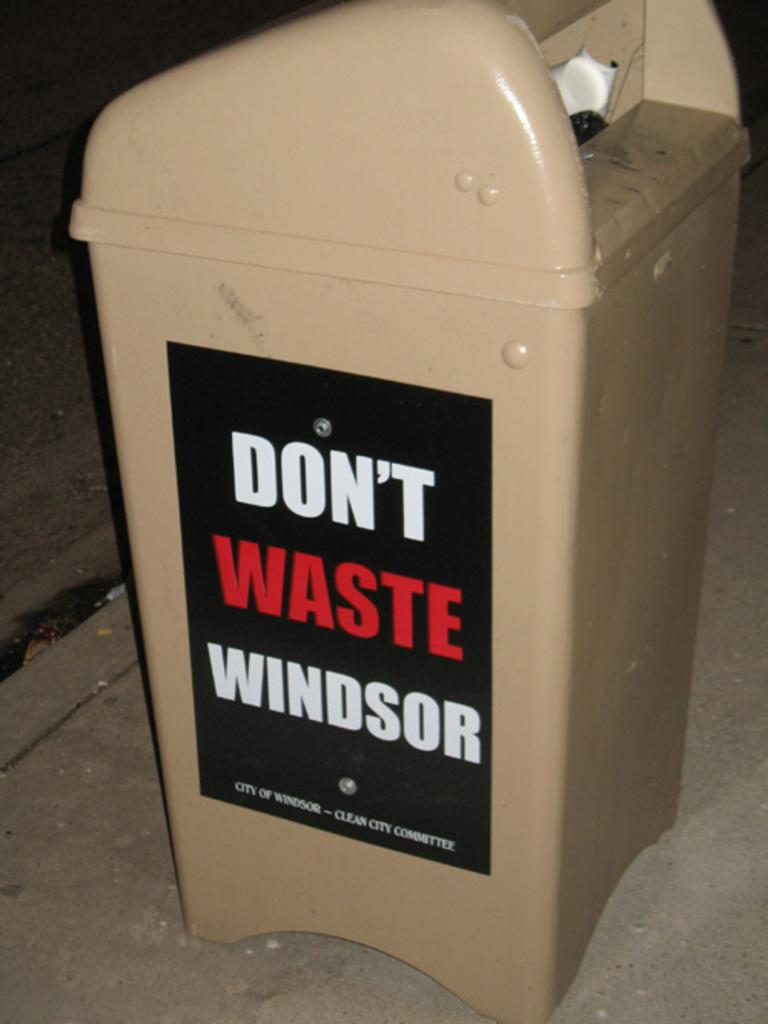<image>
Relay a brief, clear account of the picture shown. a garbage can that has a sign on the side that says 'don't waste windsor' on it 